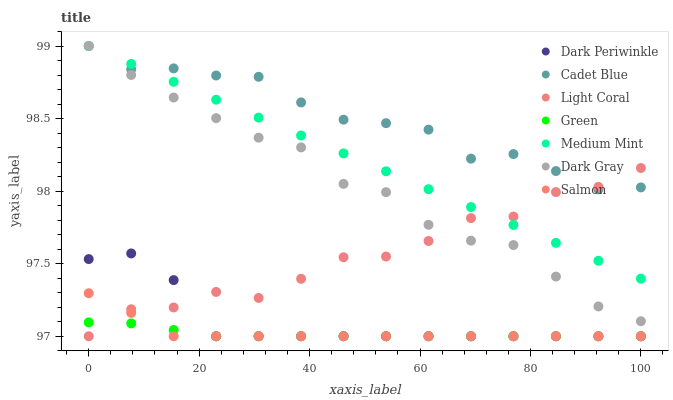Does Green have the minimum area under the curve?
Answer yes or no. Yes. Does Cadet Blue have the maximum area under the curve?
Answer yes or no. Yes. Does Dark Gray have the minimum area under the curve?
Answer yes or no. No. Does Dark Gray have the maximum area under the curve?
Answer yes or no. No. Is Medium Mint the smoothest?
Answer yes or no. Yes. Is Light Coral the roughest?
Answer yes or no. Yes. Is Dark Gray the smoothest?
Answer yes or no. No. Is Dark Gray the roughest?
Answer yes or no. No. Does Salmon have the lowest value?
Answer yes or no. Yes. Does Dark Gray have the lowest value?
Answer yes or no. No. Does Cadet Blue have the highest value?
Answer yes or no. Yes. Does Salmon have the highest value?
Answer yes or no. No. Is Green less than Cadet Blue?
Answer yes or no. Yes. Is Dark Gray greater than Dark Periwinkle?
Answer yes or no. Yes. Does Green intersect Dark Periwinkle?
Answer yes or no. Yes. Is Green less than Dark Periwinkle?
Answer yes or no. No. Is Green greater than Dark Periwinkle?
Answer yes or no. No. Does Green intersect Cadet Blue?
Answer yes or no. No. 